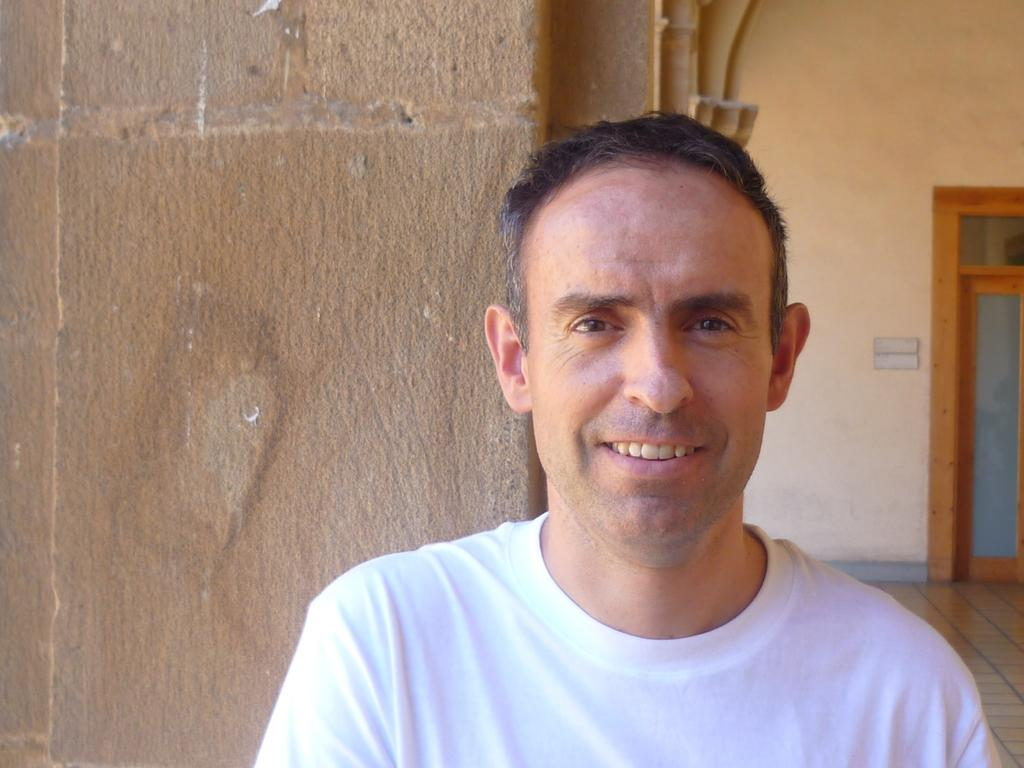Who is present in the image? There is a man in the image. Where is the man located in the image? The man is on the right side of the image. What is the man wearing? The man is wearing clothes. What is the man's facial expression? The man is smiling. What type of surface is visible in the image? There is a floor visible in the image. What type of architectural feature is visible in the image? There is a wall and a door visible in the image. What color is the tank in the image? There is no tank present in the image. 